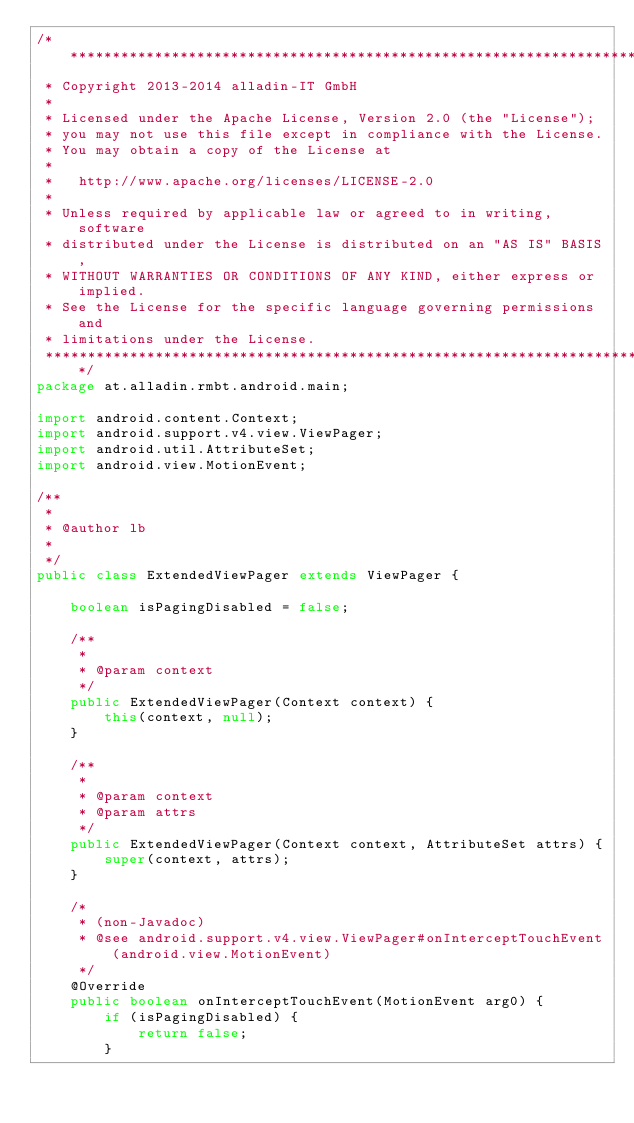Convert code to text. <code><loc_0><loc_0><loc_500><loc_500><_Java_>/*******************************************************************************
 * Copyright 2013-2014 alladin-IT GmbH
 * 
 * Licensed under the Apache License, Version 2.0 (the "License");
 * you may not use this file except in compliance with the License.
 * You may obtain a copy of the License at
 * 
 *   http://www.apache.org/licenses/LICENSE-2.0
 * 
 * Unless required by applicable law or agreed to in writing, software
 * distributed under the License is distributed on an "AS IS" BASIS,
 * WITHOUT WARRANTIES OR CONDITIONS OF ANY KIND, either express or implied.
 * See the License for the specific language governing permissions and
 * limitations under the License.
 ******************************************************************************/
package at.alladin.rmbt.android.main;

import android.content.Context;
import android.support.v4.view.ViewPager;
import android.util.AttributeSet;
import android.view.MotionEvent;

/**
 * 
 * @author lb
 *
 */
public class ExtendedViewPager extends ViewPager {

	boolean isPagingDisabled = false;

	/**
	 * 
	 * @param context
	 */
	public ExtendedViewPager(Context context) {
		this(context, null);
	}

	/**
	 * 
	 * @param context
	 * @param attrs
	 */
	public ExtendedViewPager(Context context, AttributeSet attrs) {
		super(context, attrs);
	}

	/*
	 * (non-Javadoc)
	 * @see android.support.v4.view.ViewPager#onInterceptTouchEvent(android.view.MotionEvent)
	 */
	@Override
	public boolean onInterceptTouchEvent(MotionEvent arg0) {
		if (isPagingDisabled) {
			return false;
		}
		</code> 